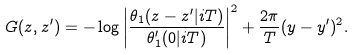<formula> <loc_0><loc_0><loc_500><loc_500>G ( z , z ^ { \prime } ) = - \log \left | \frac { \theta _ { 1 } ( z - z ^ { \prime } | i T ) } { \theta _ { 1 } ^ { \prime } ( 0 | i T ) } \right | ^ { 2 } + \frac { 2 \pi } { T } ( y - y ^ { \prime } ) ^ { 2 } .</formula> 